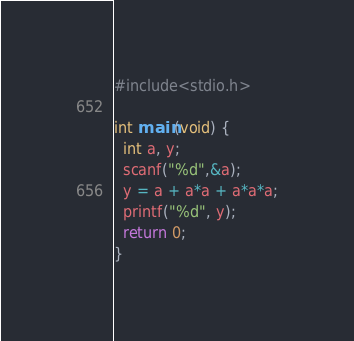Convert code to text. <code><loc_0><loc_0><loc_500><loc_500><_C_>#include<stdio.h>

int main(void) {
  int a, y;
  scanf("%d",&a);
  y = a + a*a + a*a*a;
  printf("%d", y);
  return 0;
}</code> 